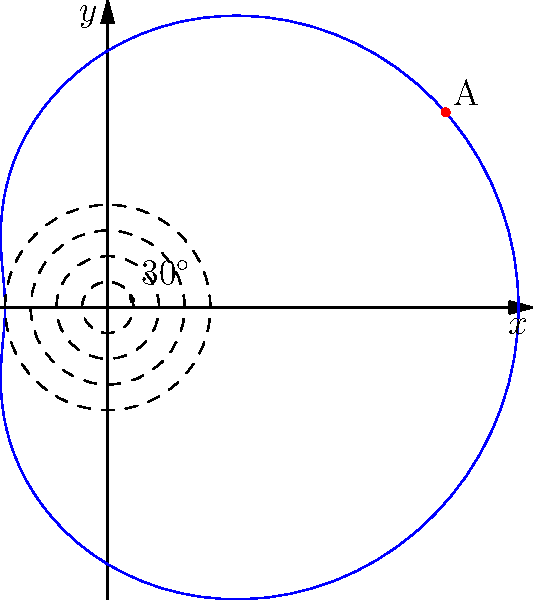A meteor's trajectory through Earth's atmosphere is modeled by the polar equation $r = 5 + 3\cos(\theta)$, where $r$ is in kilometers. At what angle $\theta$ (in radians) does the meteor reach its closest point to Earth's surface, and what is this minimum distance? To find the closest point to Earth's surface and its corresponding angle, we need to follow these steps:

1) The distance from Earth's surface is minimized when $r$ is at its minimum value.

2) To find the minimum value of $r$, we need to differentiate $r$ with respect to $\theta$ and set it to zero:

   $$\frac{dr}{d\theta} = -3\sin(\theta)$$

3) Setting this equal to zero:
   $$-3\sin(\theta) = 0$$
   $$\sin(\theta) = 0$$

4) The solutions to this equation are $\theta = 0, \pi, 2\pi, ...$ 

5) To determine which of these gives the minimum $r$, we substitute these values back into the original equation:

   For $\theta = 0$ or $2\pi$: $r = 5 + 3 = 8$
   For $\theta = \pi$: $r = 5 - 3 = 2$

6) The minimum value of $r$ occurs when $\theta = \pi$ radians.

7) The minimum distance from Earth's surface is therefore 2 kilometers.
Answer: $\theta = \pi$ radians, 2 km 